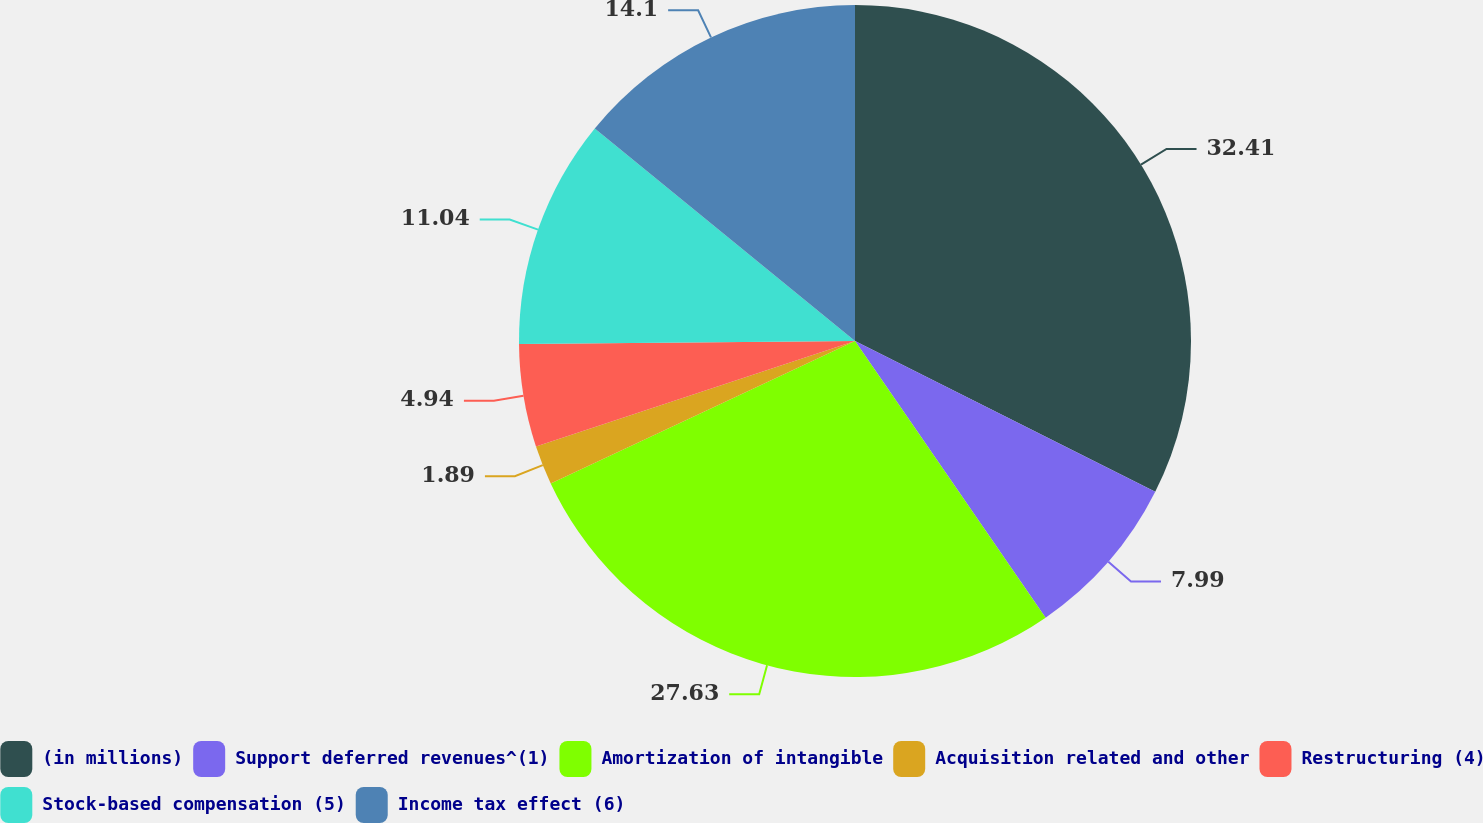Convert chart to OTSL. <chart><loc_0><loc_0><loc_500><loc_500><pie_chart><fcel>(in millions)<fcel>Support deferred revenues^(1)<fcel>Amortization of intangible<fcel>Acquisition related and other<fcel>Restructuring (4)<fcel>Stock-based compensation (5)<fcel>Income tax effect (6)<nl><fcel>32.41%<fcel>7.99%<fcel>27.63%<fcel>1.89%<fcel>4.94%<fcel>11.04%<fcel>14.1%<nl></chart> 